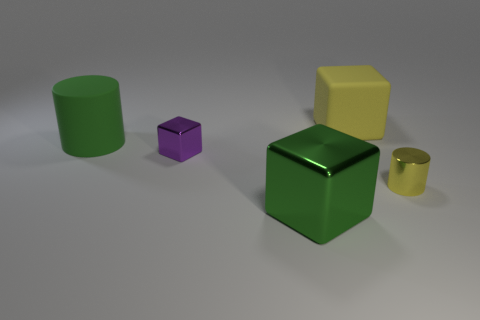Subtract all tiny purple metallic blocks. How many blocks are left? 2 Add 3 purple metal blocks. How many objects exist? 8 Subtract all blocks. How many objects are left? 2 Subtract 1 blocks. How many blocks are left? 2 Subtract all red blocks. Subtract all brown spheres. How many blocks are left? 3 Subtract all large green cylinders. Subtract all cylinders. How many objects are left? 2 Add 2 big cubes. How many big cubes are left? 4 Add 3 yellow blocks. How many yellow blocks exist? 4 Subtract 1 purple cubes. How many objects are left? 4 